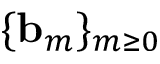<formula> <loc_0><loc_0><loc_500><loc_500>\{ { b } _ { m } \} _ { m \geq 0 }</formula> 